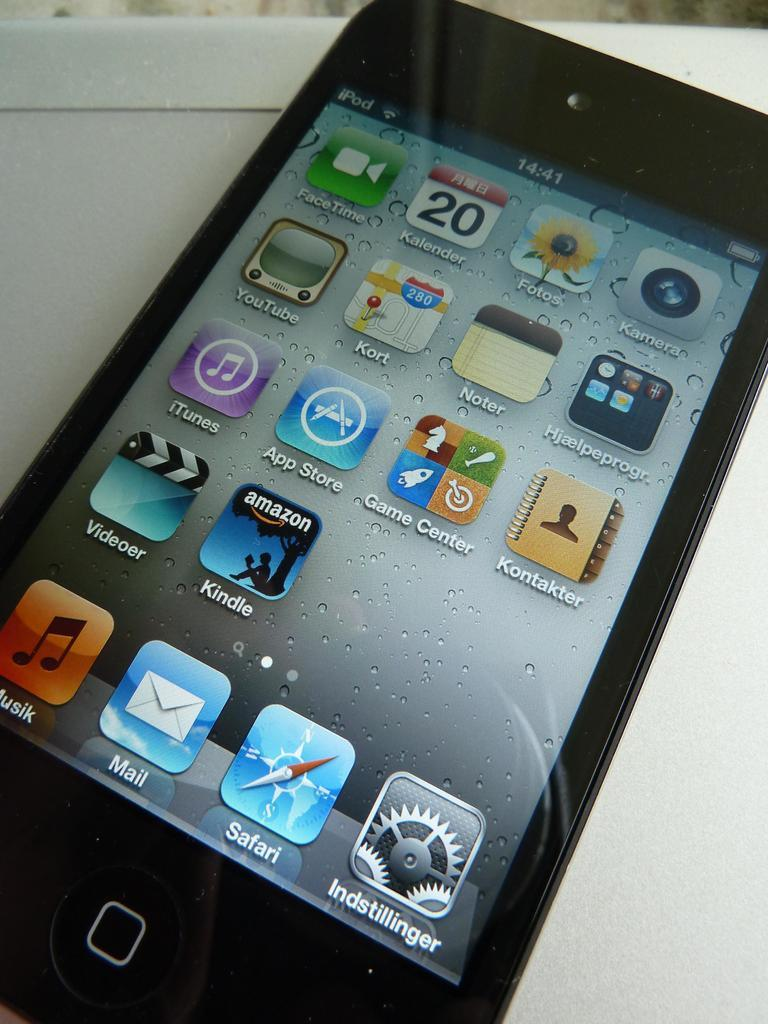<image>
Write a terse but informative summary of the picture. An iPod open to a screen full of apps such as Kindle and Safari. 